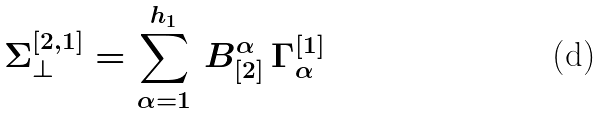Convert formula to latex. <formula><loc_0><loc_0><loc_500><loc_500>\Sigma ^ { [ 2 , 1 ] } _ { \perp } = \sum _ { \alpha = 1 } ^ { h _ { 1 } } \, B ^ { \alpha } _ { [ 2 ] } \, \Gamma ^ { [ 1 ] } _ { \alpha }</formula> 